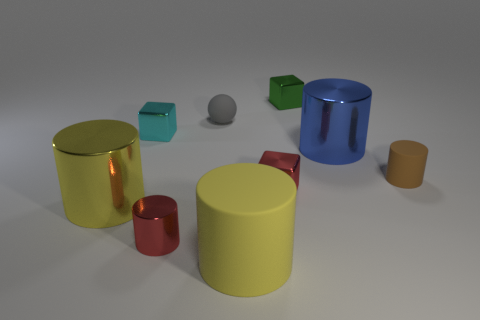Can you tell me the colors of the objects in the image? Certainly, the image showcases a variety of colors. There are two yellow cylindrical objects, one large and one small. A blue cylinder, a red cylinder and cube, a green cube, and a small gray sphere. 